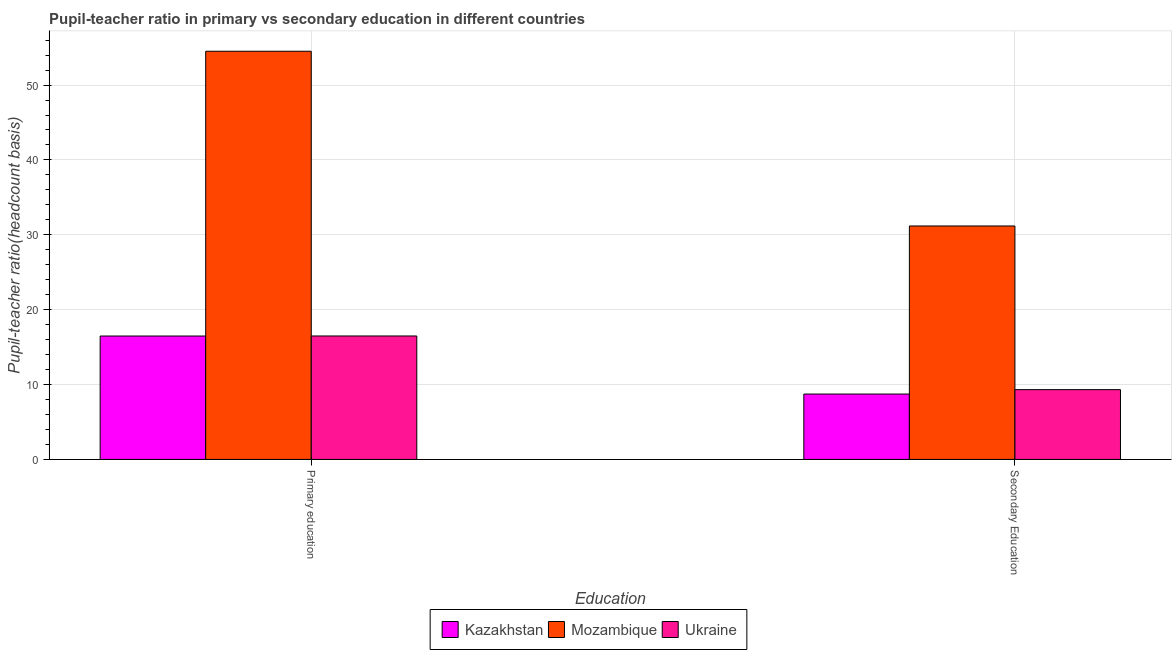How many groups of bars are there?
Offer a very short reply. 2. Are the number of bars per tick equal to the number of legend labels?
Your answer should be very brief. Yes. How many bars are there on the 1st tick from the left?
Your answer should be compact. 3. What is the label of the 2nd group of bars from the left?
Make the answer very short. Secondary Education. What is the pupil-teacher ratio in primary education in Kazakhstan?
Provide a succinct answer. 16.48. Across all countries, what is the maximum pupil-teacher ratio in primary education?
Offer a terse response. 54.52. Across all countries, what is the minimum pupil-teacher ratio in primary education?
Your answer should be compact. 16.48. In which country was the pupil teacher ratio on secondary education maximum?
Give a very brief answer. Mozambique. In which country was the pupil teacher ratio on secondary education minimum?
Ensure brevity in your answer.  Kazakhstan. What is the total pupil-teacher ratio in primary education in the graph?
Provide a short and direct response. 87.49. What is the difference between the pupil-teacher ratio in primary education in Kazakhstan and that in Mozambique?
Keep it short and to the point. -38.03. What is the difference between the pupil teacher ratio on secondary education in Ukraine and the pupil-teacher ratio in primary education in Mozambique?
Offer a very short reply. -45.2. What is the average pupil teacher ratio on secondary education per country?
Offer a very short reply. 16.41. What is the difference between the pupil teacher ratio on secondary education and pupil-teacher ratio in primary education in Ukraine?
Offer a very short reply. -7.17. What is the ratio of the pupil teacher ratio on secondary education in Kazakhstan to that in Ukraine?
Offer a terse response. 0.94. Is the pupil teacher ratio on secondary education in Ukraine less than that in Kazakhstan?
Your answer should be very brief. No. What does the 2nd bar from the left in Primary education represents?
Ensure brevity in your answer.  Mozambique. What does the 2nd bar from the right in Secondary Education represents?
Keep it short and to the point. Mozambique. How many bars are there?
Ensure brevity in your answer.  6. How many countries are there in the graph?
Make the answer very short. 3. Are the values on the major ticks of Y-axis written in scientific E-notation?
Keep it short and to the point. No. Does the graph contain any zero values?
Make the answer very short. No. Does the graph contain grids?
Ensure brevity in your answer.  Yes. What is the title of the graph?
Give a very brief answer. Pupil-teacher ratio in primary vs secondary education in different countries. What is the label or title of the X-axis?
Make the answer very short. Education. What is the label or title of the Y-axis?
Offer a terse response. Pupil-teacher ratio(headcount basis). What is the Pupil-teacher ratio(headcount basis) in Kazakhstan in Primary education?
Your response must be concise. 16.48. What is the Pupil-teacher ratio(headcount basis) of Mozambique in Primary education?
Your answer should be very brief. 54.52. What is the Pupil-teacher ratio(headcount basis) in Ukraine in Primary education?
Offer a very short reply. 16.49. What is the Pupil-teacher ratio(headcount basis) in Kazakhstan in Secondary Education?
Your answer should be compact. 8.73. What is the Pupil-teacher ratio(headcount basis) in Mozambique in Secondary Education?
Provide a succinct answer. 31.18. What is the Pupil-teacher ratio(headcount basis) of Ukraine in Secondary Education?
Provide a succinct answer. 9.32. Across all Education, what is the maximum Pupil-teacher ratio(headcount basis) in Kazakhstan?
Give a very brief answer. 16.48. Across all Education, what is the maximum Pupil-teacher ratio(headcount basis) of Mozambique?
Your answer should be very brief. 54.52. Across all Education, what is the maximum Pupil-teacher ratio(headcount basis) in Ukraine?
Ensure brevity in your answer.  16.49. Across all Education, what is the minimum Pupil-teacher ratio(headcount basis) in Kazakhstan?
Make the answer very short. 8.73. Across all Education, what is the minimum Pupil-teacher ratio(headcount basis) in Mozambique?
Offer a very short reply. 31.18. Across all Education, what is the minimum Pupil-teacher ratio(headcount basis) in Ukraine?
Make the answer very short. 9.32. What is the total Pupil-teacher ratio(headcount basis) of Kazakhstan in the graph?
Ensure brevity in your answer.  25.21. What is the total Pupil-teacher ratio(headcount basis) in Mozambique in the graph?
Keep it short and to the point. 85.7. What is the total Pupil-teacher ratio(headcount basis) in Ukraine in the graph?
Make the answer very short. 25.81. What is the difference between the Pupil-teacher ratio(headcount basis) of Kazakhstan in Primary education and that in Secondary Education?
Give a very brief answer. 7.75. What is the difference between the Pupil-teacher ratio(headcount basis) of Mozambique in Primary education and that in Secondary Education?
Provide a short and direct response. 23.34. What is the difference between the Pupil-teacher ratio(headcount basis) of Ukraine in Primary education and that in Secondary Education?
Offer a terse response. 7.17. What is the difference between the Pupil-teacher ratio(headcount basis) of Kazakhstan in Primary education and the Pupil-teacher ratio(headcount basis) of Mozambique in Secondary Education?
Give a very brief answer. -14.7. What is the difference between the Pupil-teacher ratio(headcount basis) in Kazakhstan in Primary education and the Pupil-teacher ratio(headcount basis) in Ukraine in Secondary Education?
Your response must be concise. 7.16. What is the difference between the Pupil-teacher ratio(headcount basis) of Mozambique in Primary education and the Pupil-teacher ratio(headcount basis) of Ukraine in Secondary Education?
Keep it short and to the point. 45.2. What is the average Pupil-teacher ratio(headcount basis) of Kazakhstan per Education?
Make the answer very short. 12.61. What is the average Pupil-teacher ratio(headcount basis) in Mozambique per Education?
Make the answer very short. 42.85. What is the average Pupil-teacher ratio(headcount basis) of Ukraine per Education?
Your answer should be very brief. 12.9. What is the difference between the Pupil-teacher ratio(headcount basis) of Kazakhstan and Pupil-teacher ratio(headcount basis) of Mozambique in Primary education?
Give a very brief answer. -38.03. What is the difference between the Pupil-teacher ratio(headcount basis) of Kazakhstan and Pupil-teacher ratio(headcount basis) of Ukraine in Primary education?
Give a very brief answer. -0.01. What is the difference between the Pupil-teacher ratio(headcount basis) in Mozambique and Pupil-teacher ratio(headcount basis) in Ukraine in Primary education?
Your response must be concise. 38.03. What is the difference between the Pupil-teacher ratio(headcount basis) in Kazakhstan and Pupil-teacher ratio(headcount basis) in Mozambique in Secondary Education?
Offer a very short reply. -22.45. What is the difference between the Pupil-teacher ratio(headcount basis) in Kazakhstan and Pupil-teacher ratio(headcount basis) in Ukraine in Secondary Education?
Ensure brevity in your answer.  -0.59. What is the difference between the Pupil-teacher ratio(headcount basis) of Mozambique and Pupil-teacher ratio(headcount basis) of Ukraine in Secondary Education?
Ensure brevity in your answer.  21.86. What is the ratio of the Pupil-teacher ratio(headcount basis) in Kazakhstan in Primary education to that in Secondary Education?
Your answer should be compact. 1.89. What is the ratio of the Pupil-teacher ratio(headcount basis) of Mozambique in Primary education to that in Secondary Education?
Make the answer very short. 1.75. What is the ratio of the Pupil-teacher ratio(headcount basis) in Ukraine in Primary education to that in Secondary Education?
Provide a short and direct response. 1.77. What is the difference between the highest and the second highest Pupil-teacher ratio(headcount basis) of Kazakhstan?
Keep it short and to the point. 7.75. What is the difference between the highest and the second highest Pupil-teacher ratio(headcount basis) of Mozambique?
Give a very brief answer. 23.34. What is the difference between the highest and the second highest Pupil-teacher ratio(headcount basis) of Ukraine?
Your response must be concise. 7.17. What is the difference between the highest and the lowest Pupil-teacher ratio(headcount basis) in Kazakhstan?
Offer a terse response. 7.75. What is the difference between the highest and the lowest Pupil-teacher ratio(headcount basis) of Mozambique?
Make the answer very short. 23.34. What is the difference between the highest and the lowest Pupil-teacher ratio(headcount basis) in Ukraine?
Provide a short and direct response. 7.17. 